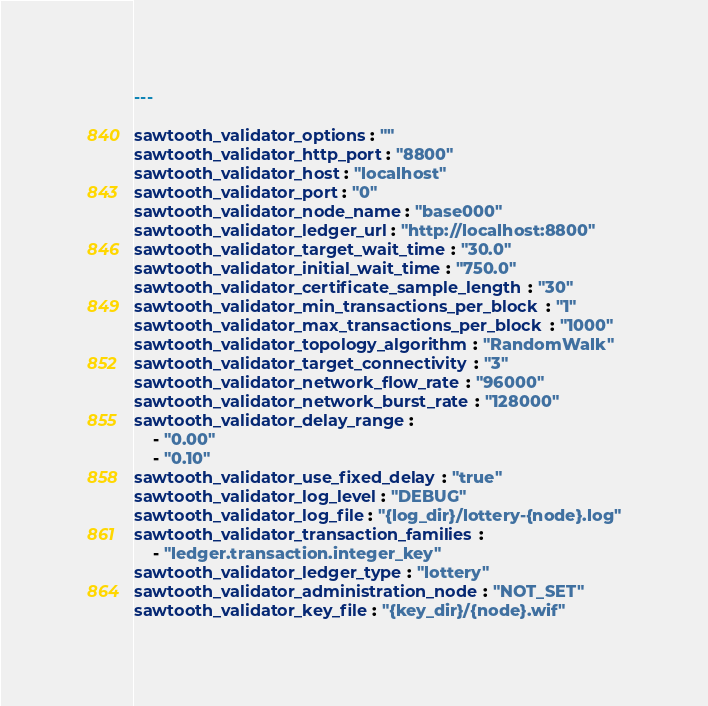<code> <loc_0><loc_0><loc_500><loc_500><_YAML_>---

sawtooth_validator_options: ""
sawtooth_validator_http_port: "8800"
sawtooth_validator_host: "localhost"
sawtooth_validator_port: "0"
sawtooth_validator_node_name: "base000"
sawtooth_validator_ledger_url: "http://localhost:8800"
sawtooth_validator_target_wait_time: "30.0"
sawtooth_validator_initial_wait_time: "750.0"
sawtooth_validator_certificate_sample_length: "30"
sawtooth_validator_min_transactions_per_block: "1"
sawtooth_validator_max_transactions_per_block: "1000"
sawtooth_validator_topology_algorithm: "RandomWalk"
sawtooth_validator_target_connectivity: "3"
sawtooth_validator_network_flow_rate: "96000"
sawtooth_validator_network_burst_rate: "128000"
sawtooth_validator_delay_range:
    - "0.00"
    - "0.10"
sawtooth_validator_use_fixed_delay: "true"
sawtooth_validator_log_level: "DEBUG"
sawtooth_validator_log_file: "{log_dir}/lottery-{node}.log"
sawtooth_validator_transaction_families:
    - "ledger.transaction.integer_key"
sawtooth_validator_ledger_type: "lottery"
sawtooth_validator_administration_node: "NOT_SET"
sawtooth_validator_key_file: "{key_dir}/{node}.wif"
</code> 